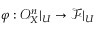<formula> <loc_0><loc_0><loc_500><loc_500>\varphi \colon { \mathcal { O } } _ { X } ^ { n } | _ { U } \to { \mathcal { F } } | _ { U }</formula> 